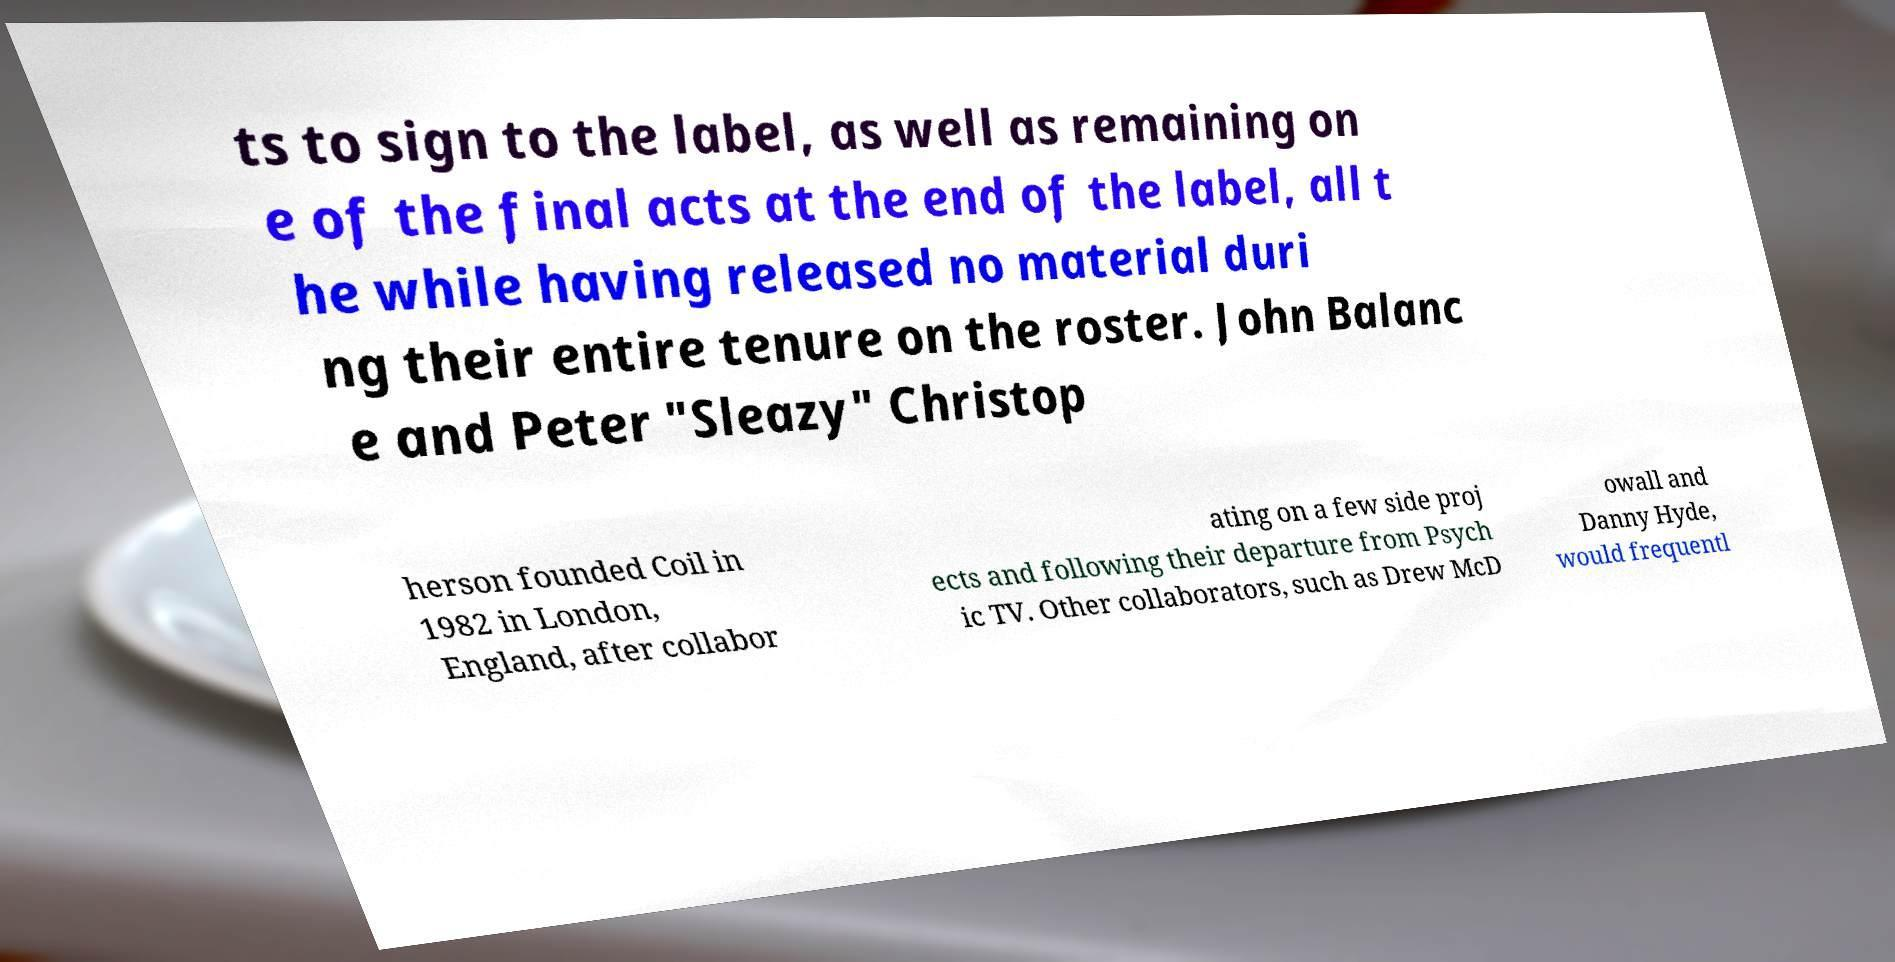For documentation purposes, I need the text within this image transcribed. Could you provide that? ts to sign to the label, as well as remaining on e of the final acts at the end of the label, all t he while having released no material duri ng their entire tenure on the roster. John Balanc e and Peter "Sleazy" Christop herson founded Coil in 1982 in London, England, after collabor ating on a few side proj ects and following their departure from Psych ic TV. Other collaborators, such as Drew McD owall and Danny Hyde, would frequentl 